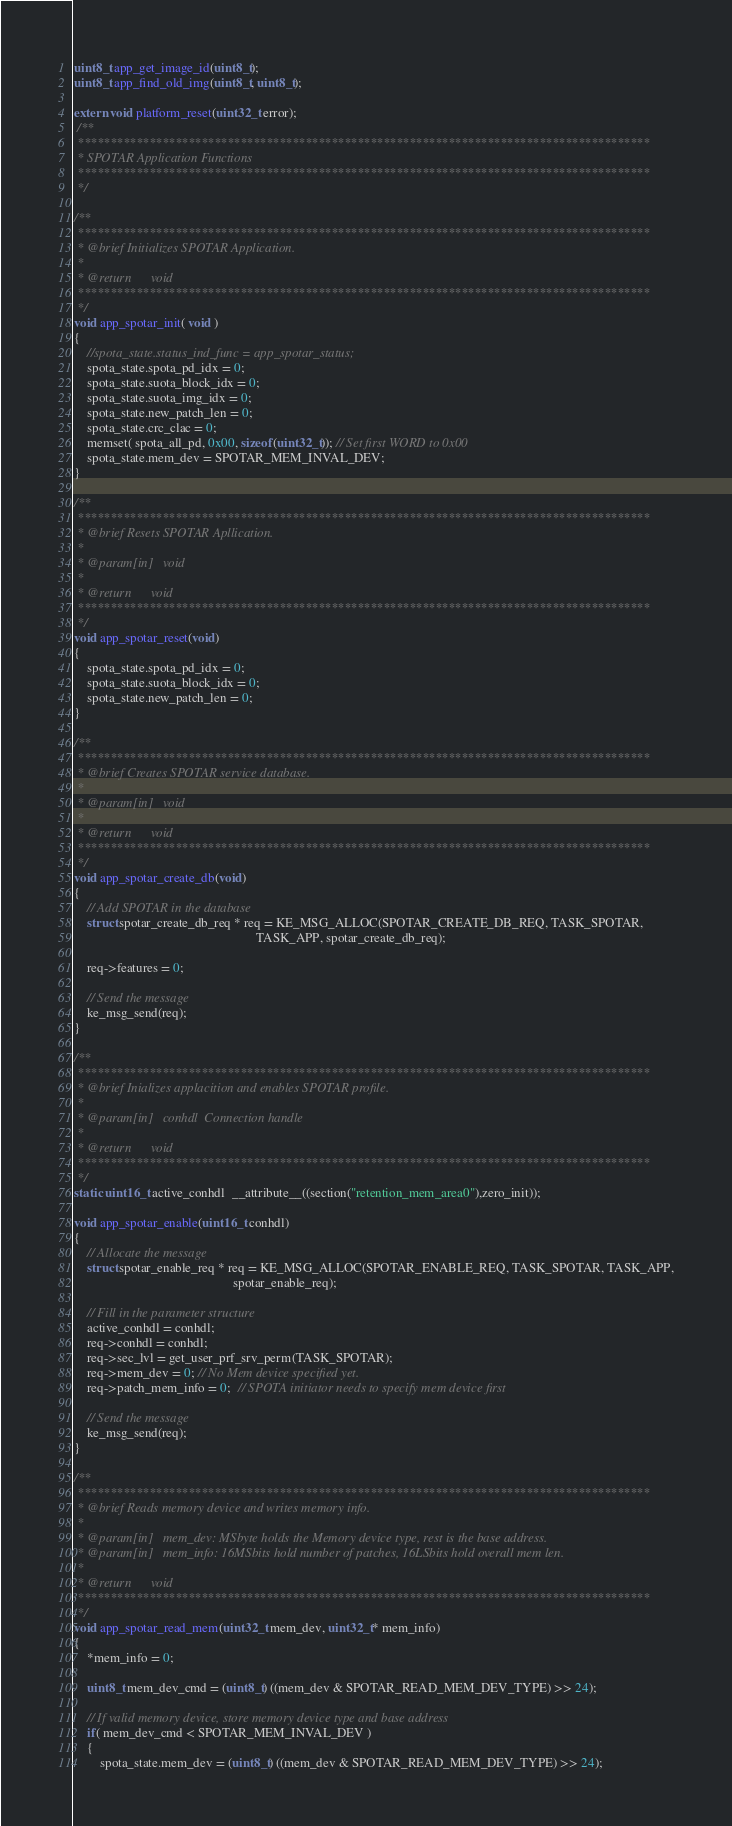Convert code to text. <code><loc_0><loc_0><loc_500><loc_500><_C_>uint8_t app_get_image_id(uint8_t);
uint8_t app_find_old_img(uint8_t, uint8_t);

extern void platform_reset(uint32_t error);
 /**
 ****************************************************************************************
 * SPOTAR Application Functions
 ****************************************************************************************
 */
 
/**
 ****************************************************************************************
 * @brief Initializes SPOTAR Application.
 *
 * @return      void
 ****************************************************************************************
 */
void app_spotar_init( void )
{	
    //spota_state.status_ind_func = app_spotar_status;
    spota_state.spota_pd_idx = 0;
    spota_state.suota_block_idx = 0;
    spota_state.suota_img_idx = 0;
    spota_state.new_patch_len = 0;
    spota_state.crc_clac = 0;
    memset( spota_all_pd, 0x00, sizeof(uint32_t)); // Set first WORD to 0x00
    spota_state.mem_dev = SPOTAR_MEM_INVAL_DEV;
}

/**
 ****************************************************************************************
 * @brief Resets SPOTAR Apllication.
 *
 * @param[in]   void
 *
 * @return      void
 ****************************************************************************************
 */
void app_spotar_reset(void)
{	
    spota_state.spota_pd_idx = 0;
    spota_state.suota_block_idx = 0;
    spota_state.new_patch_len = 0;
}

/**
 ****************************************************************************************
 * @brief Creates SPOTAR service database.
 *
 * @param[in]   void
 *
 * @return      void
 ****************************************************************************************
 */
void app_spotar_create_db(void)
{
    // Add SPOTAR in the database
    struct spotar_create_db_req * req = KE_MSG_ALLOC(SPOTAR_CREATE_DB_REQ, TASK_SPOTAR,
                                                        TASK_APP, spotar_create_db_req);

    req->features = 0;

    // Send the message
    ke_msg_send(req);
}

/**
 ****************************************************************************************
 * @brief Inializes applacition and enables SPOTAR profile.
 *
 * @param[in]   conhdl  Connection handle
 *
 * @return      void
 ****************************************************************************************
 */
static uint16_t active_conhdl  __attribute__((section("retention_mem_area0"),zero_init));

void app_spotar_enable(uint16_t conhdl)
{
    // Allocate the message
    struct spotar_enable_req * req = KE_MSG_ALLOC(SPOTAR_ENABLE_REQ, TASK_SPOTAR, TASK_APP,
                                                 spotar_enable_req);

    // Fill in the parameter structure
    active_conhdl = conhdl;
    req->conhdl = conhdl;
    req->sec_lvl = get_user_prf_srv_perm(TASK_SPOTAR);
    req->mem_dev = 0; // No Mem device specified yet.
    req->patch_mem_info = 0;  // SPOTA initiator needs to specify mem device first
    
    // Send the message
    ke_msg_send(req);
}

/**
 ****************************************************************************************
 * @brief Reads memory device and writes memory info.
 *
 * @param[in]   mem_dev: MSbyte holds the Memory device type, rest is the base address.
 * @param[in]   mem_info: 16MSbits hold number of patches, 16LSbits hold overall mem len.
 *
 * @return      void
 ****************************************************************************************
 */
void app_spotar_read_mem(uint32_t mem_dev, uint32_t* mem_info)
{  
    *mem_info = 0;
    
    uint8_t mem_dev_cmd = (uint8_t) ((mem_dev & SPOTAR_READ_MEM_DEV_TYPE) >> 24);
    
    // If valid memory device, store memory device type and base address
    if( mem_dev_cmd < SPOTAR_MEM_INVAL_DEV )
    {
        spota_state.mem_dev = (uint8_t) ((mem_dev & SPOTAR_READ_MEM_DEV_TYPE) >> 24);</code> 